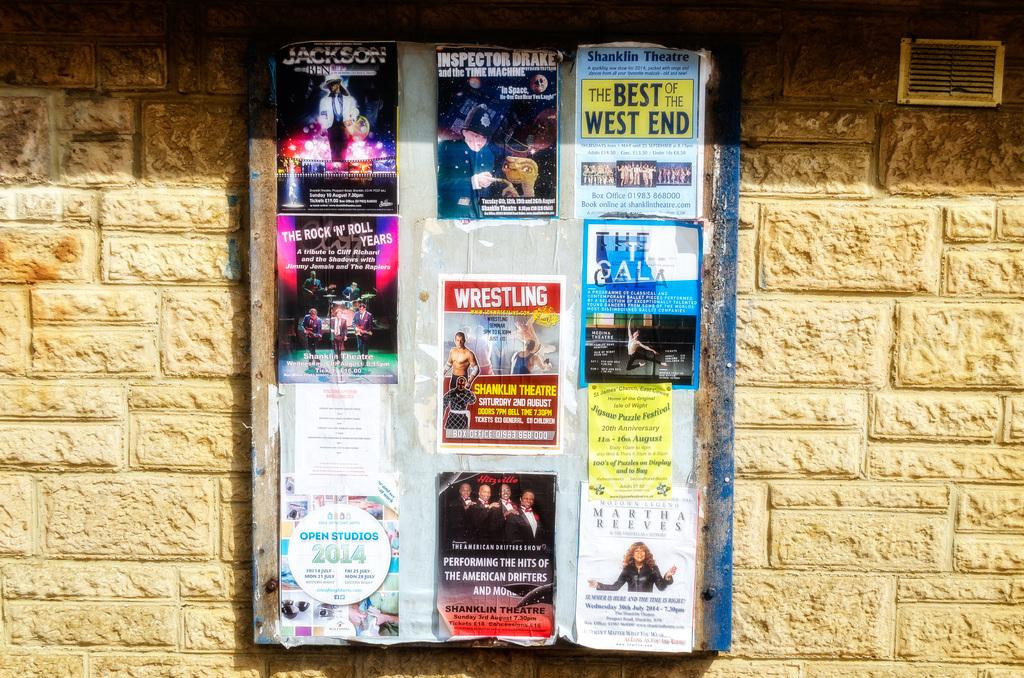What is the poster in the center about?
Your response must be concise. Wrestling. 